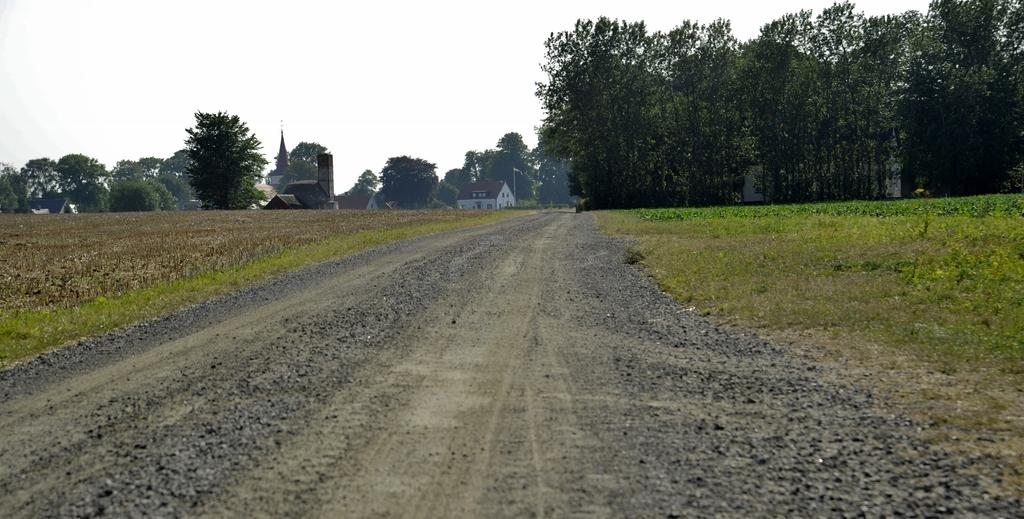What type of path is visible at the bottom of the image? There is a way at the bottom side of the image. What structures can be seen in the image? There are houses in the image. What type of vegetation is present in the image? There are trees in the image. What type of terrain is visible in the image? There is grassland in the image. What type of flame can be seen on the queen's head in the image? There is no queen or flame present in the image; it features a way, houses, trees, and grassland. 